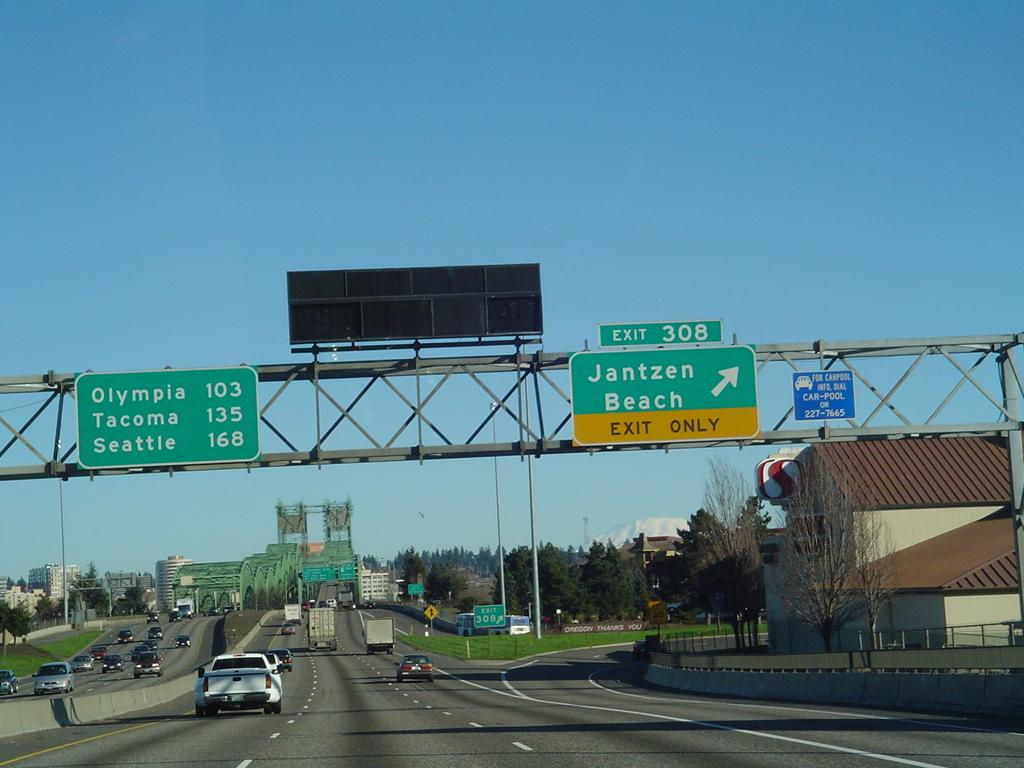Provide a one-sentence caption for the provided image. Sunny day on the a four lane highway with choices for a trip into the city or the beach. 